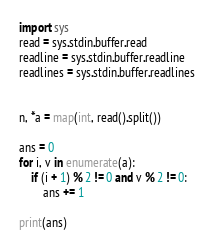Convert code to text. <code><loc_0><loc_0><loc_500><loc_500><_Python_>import sys
read = sys.stdin.buffer.read
readline = sys.stdin.buffer.readline
readlines = sys.stdin.buffer.readlines


n, *a = map(int, read().split())

ans = 0
for i, v in enumerate(a):
    if (i + 1) % 2 != 0 and v % 2 != 0:
        ans += 1

print(ans)
</code> 